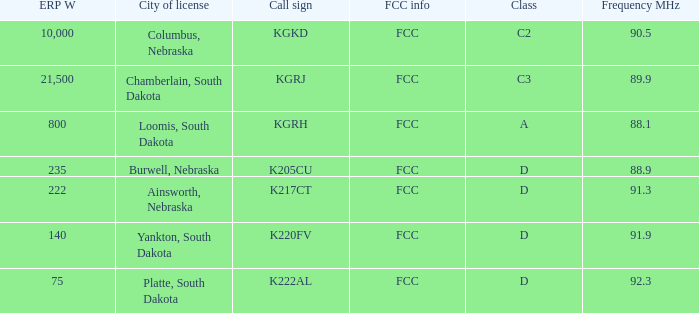What is the call sign with a 222 erp w? K217CT. 